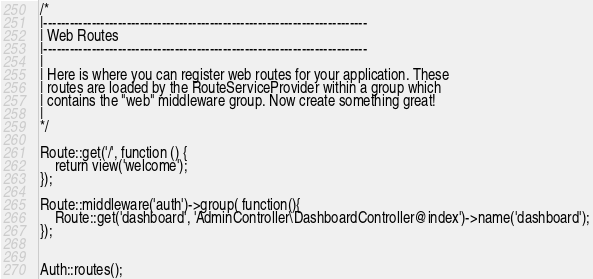<code> <loc_0><loc_0><loc_500><loc_500><_PHP_>
/*
|--------------------------------------------------------------------------
| Web Routes
|--------------------------------------------------------------------------
|
| Here is where you can register web routes for your application. These
| routes are loaded by the RouteServiceProvider within a group which
| contains the "web" middleware group. Now create something great!
|
*/

Route::get('/', function () {
    return view('welcome');
});

Route::middleware('auth')->group( function(){
	Route::get('dashboard', 'AdminController\DashboardController@index')->name('dashboard');
});


Auth::routes();

</code> 